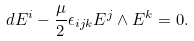Convert formula to latex. <formula><loc_0><loc_0><loc_500><loc_500>d E ^ { i } - \frac { \mu } { 2 } \epsilon _ { i j k } E ^ { j } \wedge E ^ { k } = 0 .</formula> 